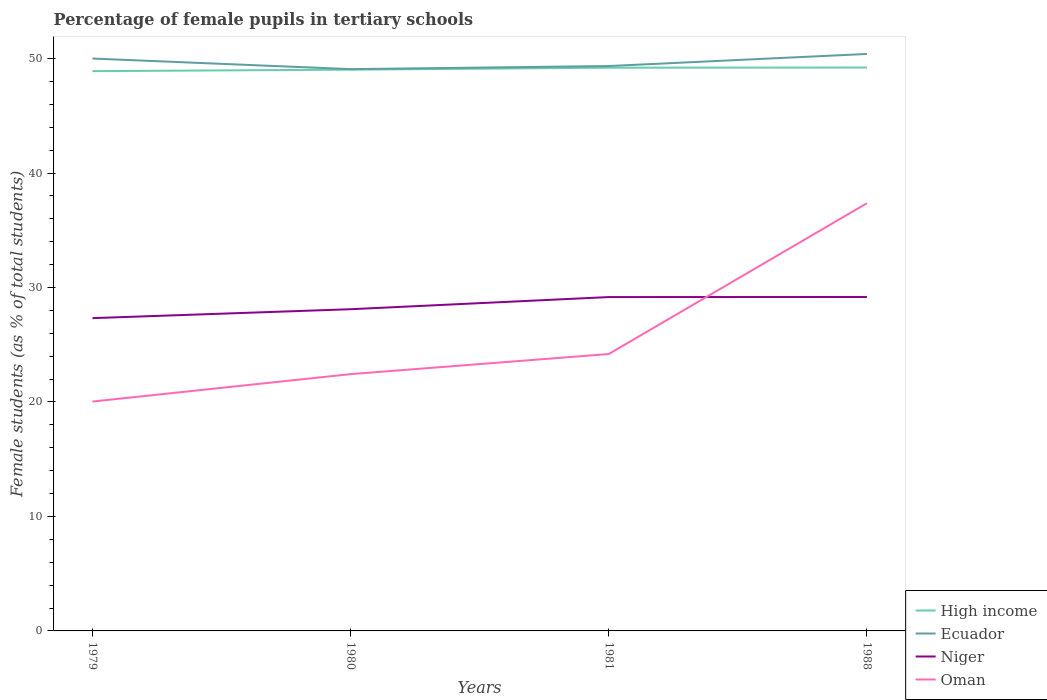Is the number of lines equal to the number of legend labels?
Give a very brief answer. Yes. Across all years, what is the maximum percentage of female pupils in tertiary schools in Ecuador?
Your response must be concise. 49.08. In which year was the percentage of female pupils in tertiary schools in High income maximum?
Your answer should be compact. 1979. What is the total percentage of female pupils in tertiary schools in High income in the graph?
Provide a short and direct response. -0.13. What is the difference between the highest and the second highest percentage of female pupils in tertiary schools in Ecuador?
Ensure brevity in your answer.  1.33. What is the difference between the highest and the lowest percentage of female pupils in tertiary schools in Niger?
Your answer should be compact. 2. How many years are there in the graph?
Your answer should be very brief. 4. What is the difference between two consecutive major ticks on the Y-axis?
Provide a succinct answer. 10. Does the graph contain any zero values?
Ensure brevity in your answer.  No. Does the graph contain grids?
Your answer should be very brief. No. Where does the legend appear in the graph?
Your answer should be very brief. Bottom right. How many legend labels are there?
Keep it short and to the point. 4. How are the legend labels stacked?
Make the answer very short. Vertical. What is the title of the graph?
Your answer should be compact. Percentage of female pupils in tertiary schools. What is the label or title of the Y-axis?
Offer a terse response. Female students (as % of total students). What is the Female students (as % of total students) of High income in 1979?
Keep it short and to the point. 48.9. What is the Female students (as % of total students) of Ecuador in 1979?
Your answer should be compact. 50. What is the Female students (as % of total students) of Niger in 1979?
Make the answer very short. 27.32. What is the Female students (as % of total students) of Oman in 1979?
Ensure brevity in your answer.  20.04. What is the Female students (as % of total students) of High income in 1980?
Your answer should be very brief. 49.03. What is the Female students (as % of total students) of Ecuador in 1980?
Your response must be concise. 49.08. What is the Female students (as % of total students) of Niger in 1980?
Your answer should be very brief. 28.1. What is the Female students (as % of total students) in Oman in 1980?
Provide a succinct answer. 22.43. What is the Female students (as % of total students) of High income in 1981?
Keep it short and to the point. 49.2. What is the Female students (as % of total students) in Ecuador in 1981?
Ensure brevity in your answer.  49.35. What is the Female students (as % of total students) in Niger in 1981?
Your response must be concise. 29.17. What is the Female students (as % of total students) of Oman in 1981?
Offer a terse response. 24.19. What is the Female students (as % of total students) of High income in 1988?
Your answer should be very brief. 49.22. What is the Female students (as % of total students) in Ecuador in 1988?
Your answer should be compact. 50.4. What is the Female students (as % of total students) in Niger in 1988?
Offer a terse response. 29.17. What is the Female students (as % of total students) in Oman in 1988?
Your answer should be compact. 37.36. Across all years, what is the maximum Female students (as % of total students) in High income?
Your answer should be very brief. 49.22. Across all years, what is the maximum Female students (as % of total students) in Ecuador?
Your response must be concise. 50.4. Across all years, what is the maximum Female students (as % of total students) in Niger?
Ensure brevity in your answer.  29.17. Across all years, what is the maximum Female students (as % of total students) in Oman?
Make the answer very short. 37.36. Across all years, what is the minimum Female students (as % of total students) in High income?
Provide a succinct answer. 48.9. Across all years, what is the minimum Female students (as % of total students) in Ecuador?
Give a very brief answer. 49.08. Across all years, what is the minimum Female students (as % of total students) of Niger?
Ensure brevity in your answer.  27.32. Across all years, what is the minimum Female students (as % of total students) in Oman?
Provide a short and direct response. 20.04. What is the total Female students (as % of total students) of High income in the graph?
Provide a succinct answer. 196.35. What is the total Female students (as % of total students) in Ecuador in the graph?
Your answer should be compact. 198.83. What is the total Female students (as % of total students) in Niger in the graph?
Your response must be concise. 113.76. What is the total Female students (as % of total students) in Oman in the graph?
Make the answer very short. 104.02. What is the difference between the Female students (as % of total students) of High income in 1979 and that in 1980?
Your answer should be very brief. -0.13. What is the difference between the Female students (as % of total students) in Ecuador in 1979 and that in 1980?
Offer a very short reply. 0.93. What is the difference between the Female students (as % of total students) of Niger in 1979 and that in 1980?
Ensure brevity in your answer.  -0.78. What is the difference between the Female students (as % of total students) in Oman in 1979 and that in 1980?
Your answer should be compact. -2.4. What is the difference between the Female students (as % of total students) of High income in 1979 and that in 1981?
Offer a terse response. -0.3. What is the difference between the Female students (as % of total students) in Ecuador in 1979 and that in 1981?
Make the answer very short. 0.66. What is the difference between the Female students (as % of total students) in Niger in 1979 and that in 1981?
Offer a terse response. -1.84. What is the difference between the Female students (as % of total students) in Oman in 1979 and that in 1981?
Provide a succinct answer. -4.15. What is the difference between the Female students (as % of total students) in High income in 1979 and that in 1988?
Your answer should be compact. -0.31. What is the difference between the Female students (as % of total students) of Ecuador in 1979 and that in 1988?
Offer a very short reply. -0.4. What is the difference between the Female students (as % of total students) of Niger in 1979 and that in 1988?
Offer a terse response. -1.85. What is the difference between the Female students (as % of total students) of Oman in 1979 and that in 1988?
Offer a terse response. -17.33. What is the difference between the Female students (as % of total students) of High income in 1980 and that in 1981?
Ensure brevity in your answer.  -0.17. What is the difference between the Female students (as % of total students) in Ecuador in 1980 and that in 1981?
Offer a very short reply. -0.27. What is the difference between the Female students (as % of total students) in Niger in 1980 and that in 1981?
Offer a very short reply. -1.06. What is the difference between the Female students (as % of total students) in Oman in 1980 and that in 1981?
Your answer should be compact. -1.76. What is the difference between the Female students (as % of total students) of High income in 1980 and that in 1988?
Your answer should be very brief. -0.19. What is the difference between the Female students (as % of total students) of Ecuador in 1980 and that in 1988?
Provide a short and direct response. -1.33. What is the difference between the Female students (as % of total students) of Niger in 1980 and that in 1988?
Your answer should be compact. -1.07. What is the difference between the Female students (as % of total students) in Oman in 1980 and that in 1988?
Make the answer very short. -14.93. What is the difference between the Female students (as % of total students) of High income in 1981 and that in 1988?
Offer a very short reply. -0.01. What is the difference between the Female students (as % of total students) of Ecuador in 1981 and that in 1988?
Make the answer very short. -1.06. What is the difference between the Female students (as % of total students) of Niger in 1981 and that in 1988?
Make the answer very short. -0.01. What is the difference between the Female students (as % of total students) of Oman in 1981 and that in 1988?
Your answer should be very brief. -13.17. What is the difference between the Female students (as % of total students) of High income in 1979 and the Female students (as % of total students) of Ecuador in 1980?
Your response must be concise. -0.17. What is the difference between the Female students (as % of total students) in High income in 1979 and the Female students (as % of total students) in Niger in 1980?
Ensure brevity in your answer.  20.8. What is the difference between the Female students (as % of total students) in High income in 1979 and the Female students (as % of total students) in Oman in 1980?
Ensure brevity in your answer.  26.47. What is the difference between the Female students (as % of total students) in Ecuador in 1979 and the Female students (as % of total students) in Niger in 1980?
Keep it short and to the point. 21.9. What is the difference between the Female students (as % of total students) of Ecuador in 1979 and the Female students (as % of total students) of Oman in 1980?
Your answer should be very brief. 27.57. What is the difference between the Female students (as % of total students) in Niger in 1979 and the Female students (as % of total students) in Oman in 1980?
Provide a short and direct response. 4.89. What is the difference between the Female students (as % of total students) in High income in 1979 and the Female students (as % of total students) in Ecuador in 1981?
Make the answer very short. -0.44. What is the difference between the Female students (as % of total students) of High income in 1979 and the Female students (as % of total students) of Niger in 1981?
Give a very brief answer. 19.74. What is the difference between the Female students (as % of total students) in High income in 1979 and the Female students (as % of total students) in Oman in 1981?
Provide a short and direct response. 24.71. What is the difference between the Female students (as % of total students) in Ecuador in 1979 and the Female students (as % of total students) in Niger in 1981?
Make the answer very short. 20.84. What is the difference between the Female students (as % of total students) of Ecuador in 1979 and the Female students (as % of total students) of Oman in 1981?
Your answer should be compact. 25.81. What is the difference between the Female students (as % of total students) of Niger in 1979 and the Female students (as % of total students) of Oman in 1981?
Your response must be concise. 3.13. What is the difference between the Female students (as % of total students) of High income in 1979 and the Female students (as % of total students) of Ecuador in 1988?
Your answer should be compact. -1.5. What is the difference between the Female students (as % of total students) in High income in 1979 and the Female students (as % of total students) in Niger in 1988?
Keep it short and to the point. 19.73. What is the difference between the Female students (as % of total students) in High income in 1979 and the Female students (as % of total students) in Oman in 1988?
Give a very brief answer. 11.54. What is the difference between the Female students (as % of total students) in Ecuador in 1979 and the Female students (as % of total students) in Niger in 1988?
Provide a succinct answer. 20.83. What is the difference between the Female students (as % of total students) of Ecuador in 1979 and the Female students (as % of total students) of Oman in 1988?
Keep it short and to the point. 12.64. What is the difference between the Female students (as % of total students) of Niger in 1979 and the Female students (as % of total students) of Oman in 1988?
Offer a very short reply. -10.04. What is the difference between the Female students (as % of total students) of High income in 1980 and the Female students (as % of total students) of Ecuador in 1981?
Your answer should be compact. -0.32. What is the difference between the Female students (as % of total students) in High income in 1980 and the Female students (as % of total students) in Niger in 1981?
Ensure brevity in your answer.  19.86. What is the difference between the Female students (as % of total students) in High income in 1980 and the Female students (as % of total students) in Oman in 1981?
Keep it short and to the point. 24.84. What is the difference between the Female students (as % of total students) in Ecuador in 1980 and the Female students (as % of total students) in Niger in 1981?
Give a very brief answer. 19.91. What is the difference between the Female students (as % of total students) of Ecuador in 1980 and the Female students (as % of total students) of Oman in 1981?
Keep it short and to the point. 24.89. What is the difference between the Female students (as % of total students) in Niger in 1980 and the Female students (as % of total students) in Oman in 1981?
Provide a succinct answer. 3.91. What is the difference between the Female students (as % of total students) of High income in 1980 and the Female students (as % of total students) of Ecuador in 1988?
Your answer should be very brief. -1.37. What is the difference between the Female students (as % of total students) of High income in 1980 and the Female students (as % of total students) of Niger in 1988?
Your answer should be very brief. 19.86. What is the difference between the Female students (as % of total students) in High income in 1980 and the Female students (as % of total students) in Oman in 1988?
Your answer should be compact. 11.67. What is the difference between the Female students (as % of total students) in Ecuador in 1980 and the Female students (as % of total students) in Niger in 1988?
Your response must be concise. 19.91. What is the difference between the Female students (as % of total students) of Ecuador in 1980 and the Female students (as % of total students) of Oman in 1988?
Make the answer very short. 11.71. What is the difference between the Female students (as % of total students) of Niger in 1980 and the Female students (as % of total students) of Oman in 1988?
Offer a very short reply. -9.26. What is the difference between the Female students (as % of total students) in High income in 1981 and the Female students (as % of total students) in Ecuador in 1988?
Your answer should be very brief. -1.2. What is the difference between the Female students (as % of total students) of High income in 1981 and the Female students (as % of total students) of Niger in 1988?
Offer a terse response. 20.03. What is the difference between the Female students (as % of total students) in High income in 1981 and the Female students (as % of total students) in Oman in 1988?
Make the answer very short. 11.84. What is the difference between the Female students (as % of total students) of Ecuador in 1981 and the Female students (as % of total students) of Niger in 1988?
Your answer should be very brief. 20.18. What is the difference between the Female students (as % of total students) in Ecuador in 1981 and the Female students (as % of total students) in Oman in 1988?
Provide a succinct answer. 11.98. What is the difference between the Female students (as % of total students) of Niger in 1981 and the Female students (as % of total students) of Oman in 1988?
Ensure brevity in your answer.  -8.2. What is the average Female students (as % of total students) of High income per year?
Offer a terse response. 49.09. What is the average Female students (as % of total students) in Ecuador per year?
Ensure brevity in your answer.  49.71. What is the average Female students (as % of total students) in Niger per year?
Your answer should be very brief. 28.44. What is the average Female students (as % of total students) of Oman per year?
Make the answer very short. 26.01. In the year 1979, what is the difference between the Female students (as % of total students) of High income and Female students (as % of total students) of Ecuador?
Keep it short and to the point. -1.1. In the year 1979, what is the difference between the Female students (as % of total students) of High income and Female students (as % of total students) of Niger?
Your answer should be compact. 21.58. In the year 1979, what is the difference between the Female students (as % of total students) in High income and Female students (as % of total students) in Oman?
Ensure brevity in your answer.  28.86. In the year 1979, what is the difference between the Female students (as % of total students) of Ecuador and Female students (as % of total students) of Niger?
Your answer should be very brief. 22.68. In the year 1979, what is the difference between the Female students (as % of total students) of Ecuador and Female students (as % of total students) of Oman?
Your response must be concise. 29.96. In the year 1979, what is the difference between the Female students (as % of total students) in Niger and Female students (as % of total students) in Oman?
Ensure brevity in your answer.  7.29. In the year 1980, what is the difference between the Female students (as % of total students) of High income and Female students (as % of total students) of Ecuador?
Ensure brevity in your answer.  -0.05. In the year 1980, what is the difference between the Female students (as % of total students) of High income and Female students (as % of total students) of Niger?
Offer a very short reply. 20.93. In the year 1980, what is the difference between the Female students (as % of total students) in High income and Female students (as % of total students) in Oman?
Give a very brief answer. 26.6. In the year 1980, what is the difference between the Female students (as % of total students) of Ecuador and Female students (as % of total students) of Niger?
Your answer should be compact. 20.97. In the year 1980, what is the difference between the Female students (as % of total students) in Ecuador and Female students (as % of total students) in Oman?
Provide a short and direct response. 26.64. In the year 1980, what is the difference between the Female students (as % of total students) of Niger and Female students (as % of total students) of Oman?
Give a very brief answer. 5.67. In the year 1981, what is the difference between the Female students (as % of total students) of High income and Female students (as % of total students) of Ecuador?
Offer a terse response. -0.14. In the year 1981, what is the difference between the Female students (as % of total students) of High income and Female students (as % of total students) of Niger?
Provide a short and direct response. 20.04. In the year 1981, what is the difference between the Female students (as % of total students) of High income and Female students (as % of total students) of Oman?
Your response must be concise. 25.01. In the year 1981, what is the difference between the Female students (as % of total students) of Ecuador and Female students (as % of total students) of Niger?
Your answer should be very brief. 20.18. In the year 1981, what is the difference between the Female students (as % of total students) of Ecuador and Female students (as % of total students) of Oman?
Your answer should be very brief. 25.16. In the year 1981, what is the difference between the Female students (as % of total students) in Niger and Female students (as % of total students) in Oman?
Your answer should be compact. 4.98. In the year 1988, what is the difference between the Female students (as % of total students) in High income and Female students (as % of total students) in Ecuador?
Give a very brief answer. -1.19. In the year 1988, what is the difference between the Female students (as % of total students) of High income and Female students (as % of total students) of Niger?
Make the answer very short. 20.04. In the year 1988, what is the difference between the Female students (as % of total students) of High income and Female students (as % of total students) of Oman?
Provide a succinct answer. 11.85. In the year 1988, what is the difference between the Female students (as % of total students) of Ecuador and Female students (as % of total students) of Niger?
Give a very brief answer. 21.23. In the year 1988, what is the difference between the Female students (as % of total students) of Ecuador and Female students (as % of total students) of Oman?
Provide a short and direct response. 13.04. In the year 1988, what is the difference between the Female students (as % of total students) of Niger and Female students (as % of total students) of Oman?
Your answer should be very brief. -8.19. What is the ratio of the Female students (as % of total students) in Ecuador in 1979 to that in 1980?
Your answer should be very brief. 1.02. What is the ratio of the Female students (as % of total students) in Niger in 1979 to that in 1980?
Make the answer very short. 0.97. What is the ratio of the Female students (as % of total students) of Oman in 1979 to that in 1980?
Offer a very short reply. 0.89. What is the ratio of the Female students (as % of total students) in High income in 1979 to that in 1981?
Make the answer very short. 0.99. What is the ratio of the Female students (as % of total students) in Ecuador in 1979 to that in 1981?
Make the answer very short. 1.01. What is the ratio of the Female students (as % of total students) of Niger in 1979 to that in 1981?
Make the answer very short. 0.94. What is the ratio of the Female students (as % of total students) of Oman in 1979 to that in 1981?
Ensure brevity in your answer.  0.83. What is the ratio of the Female students (as % of total students) in High income in 1979 to that in 1988?
Offer a terse response. 0.99. What is the ratio of the Female students (as % of total students) of Niger in 1979 to that in 1988?
Your answer should be very brief. 0.94. What is the ratio of the Female students (as % of total students) of Oman in 1979 to that in 1988?
Your answer should be very brief. 0.54. What is the ratio of the Female students (as % of total students) of High income in 1980 to that in 1981?
Give a very brief answer. 1. What is the ratio of the Female students (as % of total students) of Ecuador in 1980 to that in 1981?
Provide a short and direct response. 0.99. What is the ratio of the Female students (as % of total students) of Niger in 1980 to that in 1981?
Offer a very short reply. 0.96. What is the ratio of the Female students (as % of total students) in Oman in 1980 to that in 1981?
Give a very brief answer. 0.93. What is the ratio of the Female students (as % of total students) in Ecuador in 1980 to that in 1988?
Offer a terse response. 0.97. What is the ratio of the Female students (as % of total students) of Niger in 1980 to that in 1988?
Offer a very short reply. 0.96. What is the ratio of the Female students (as % of total students) of Oman in 1980 to that in 1988?
Make the answer very short. 0.6. What is the ratio of the Female students (as % of total students) of High income in 1981 to that in 1988?
Your answer should be compact. 1. What is the ratio of the Female students (as % of total students) in Oman in 1981 to that in 1988?
Your answer should be compact. 0.65. What is the difference between the highest and the second highest Female students (as % of total students) of High income?
Give a very brief answer. 0.01. What is the difference between the highest and the second highest Female students (as % of total students) in Ecuador?
Your answer should be very brief. 0.4. What is the difference between the highest and the second highest Female students (as % of total students) of Niger?
Provide a succinct answer. 0.01. What is the difference between the highest and the second highest Female students (as % of total students) of Oman?
Your answer should be compact. 13.17. What is the difference between the highest and the lowest Female students (as % of total students) in High income?
Ensure brevity in your answer.  0.31. What is the difference between the highest and the lowest Female students (as % of total students) of Ecuador?
Provide a succinct answer. 1.33. What is the difference between the highest and the lowest Female students (as % of total students) in Niger?
Make the answer very short. 1.85. What is the difference between the highest and the lowest Female students (as % of total students) of Oman?
Ensure brevity in your answer.  17.33. 